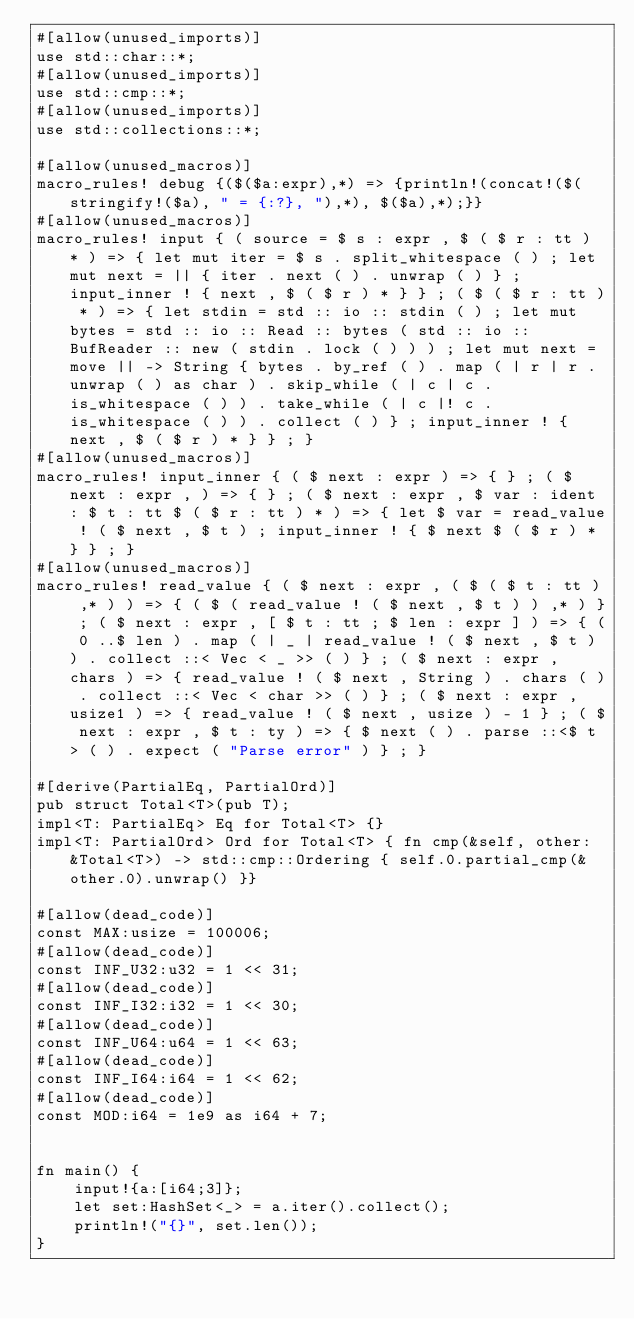<code> <loc_0><loc_0><loc_500><loc_500><_Rust_>#[allow(unused_imports)]
use std::char::*;
#[allow(unused_imports)]
use std::cmp::*;
#[allow(unused_imports)]
use std::collections::*;

#[allow(unused_macros)]
macro_rules! debug {($($a:expr),*) => {println!(concat!($(stringify!($a), " = {:?}, "),*), $($a),*);}}
#[allow(unused_macros)]
macro_rules! input { ( source = $ s : expr , $ ( $ r : tt ) * ) => { let mut iter = $ s . split_whitespace ( ) ; let mut next = || { iter . next ( ) . unwrap ( ) } ; input_inner ! { next , $ ( $ r ) * } } ; ( $ ( $ r : tt ) * ) => { let stdin = std :: io :: stdin ( ) ; let mut bytes = std :: io :: Read :: bytes ( std :: io :: BufReader :: new ( stdin . lock ( ) ) ) ; let mut next = move || -> String { bytes . by_ref ( ) . map ( | r | r . unwrap ( ) as char ) . skip_while ( | c | c . is_whitespace ( ) ) . take_while ( | c |! c . is_whitespace ( ) ) . collect ( ) } ; input_inner ! { next , $ ( $ r ) * } } ; }
#[allow(unused_macros)]
macro_rules! input_inner { ( $ next : expr ) => { } ; ( $ next : expr , ) => { } ; ( $ next : expr , $ var : ident : $ t : tt $ ( $ r : tt ) * ) => { let $ var = read_value ! ( $ next , $ t ) ; input_inner ! { $ next $ ( $ r ) * } } ; }
#[allow(unused_macros)]
macro_rules! read_value { ( $ next : expr , ( $ ( $ t : tt ) ,* ) ) => { ( $ ( read_value ! ( $ next , $ t ) ) ,* ) } ; ( $ next : expr , [ $ t : tt ; $ len : expr ] ) => { ( 0 ..$ len ) . map ( | _ | read_value ! ( $ next , $ t ) ) . collect ::< Vec < _ >> ( ) } ; ( $ next : expr , chars ) => { read_value ! ( $ next , String ) . chars ( ) . collect ::< Vec < char >> ( ) } ; ( $ next : expr , usize1 ) => { read_value ! ( $ next , usize ) - 1 } ; ( $ next : expr , $ t : ty ) => { $ next ( ) . parse ::<$ t > ( ) . expect ( "Parse error" ) } ; }

#[derive(PartialEq, PartialOrd)]
pub struct Total<T>(pub T);
impl<T: PartialEq> Eq for Total<T> {}
impl<T: PartialOrd> Ord for Total<T> { fn cmp(&self, other: &Total<T>) -> std::cmp::Ordering { self.0.partial_cmp(&other.0).unwrap() }}

#[allow(dead_code)]
const MAX:usize = 100006;
#[allow(dead_code)]
const INF_U32:u32 = 1 << 31;
#[allow(dead_code)]
const INF_I32:i32 = 1 << 30;
#[allow(dead_code)]
const INF_U64:u64 = 1 << 63;
#[allow(dead_code)]
const INF_I64:i64 = 1 << 62;
#[allow(dead_code)]
const MOD:i64 = 1e9 as i64 + 7;


fn main() {
    input!{a:[i64;3]};
    let set:HashSet<_> = a.iter().collect();
    println!("{}", set.len());
}
</code> 